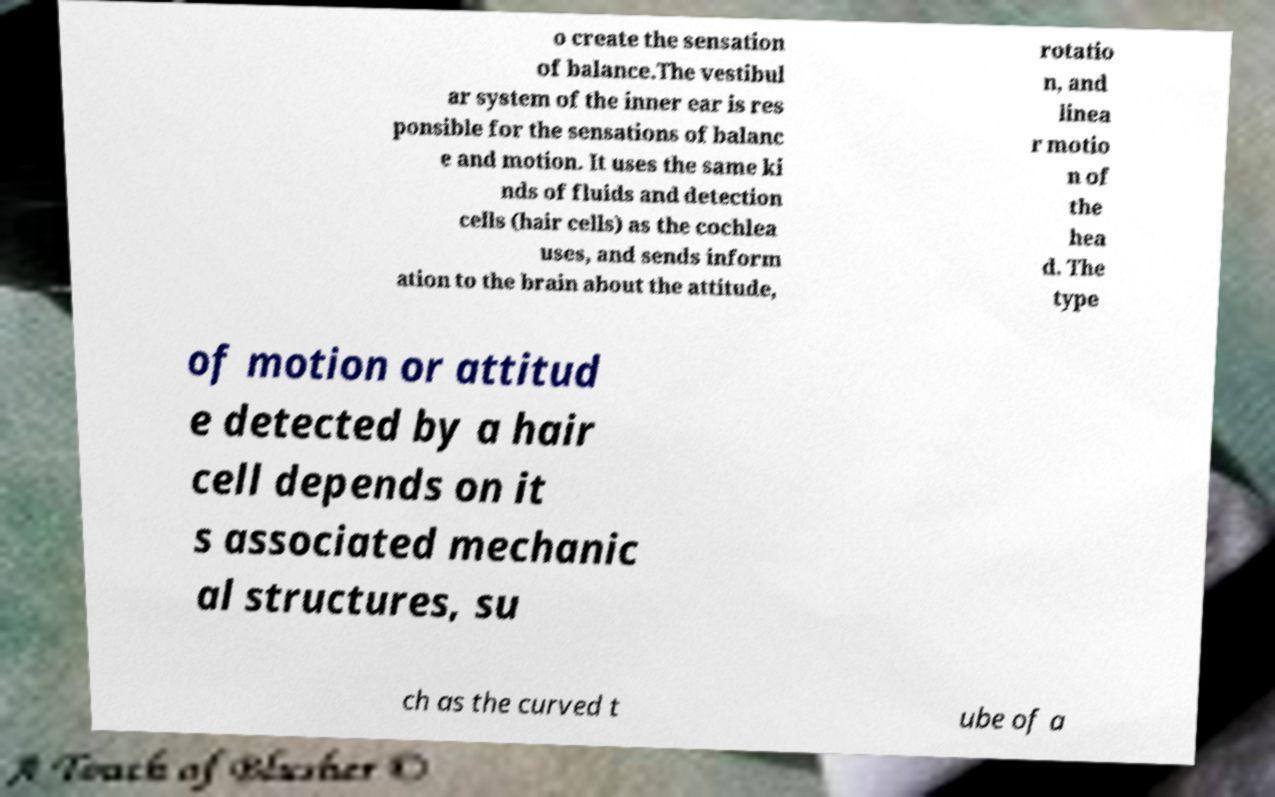Can you read and provide the text displayed in the image?This photo seems to have some interesting text. Can you extract and type it out for me? o create the sensation of balance.The vestibul ar system of the inner ear is res ponsible for the sensations of balanc e and motion. It uses the same ki nds of fluids and detection cells (hair cells) as the cochlea uses, and sends inform ation to the brain about the attitude, rotatio n, and linea r motio n of the hea d. The type of motion or attitud e detected by a hair cell depends on it s associated mechanic al structures, su ch as the curved t ube of a 